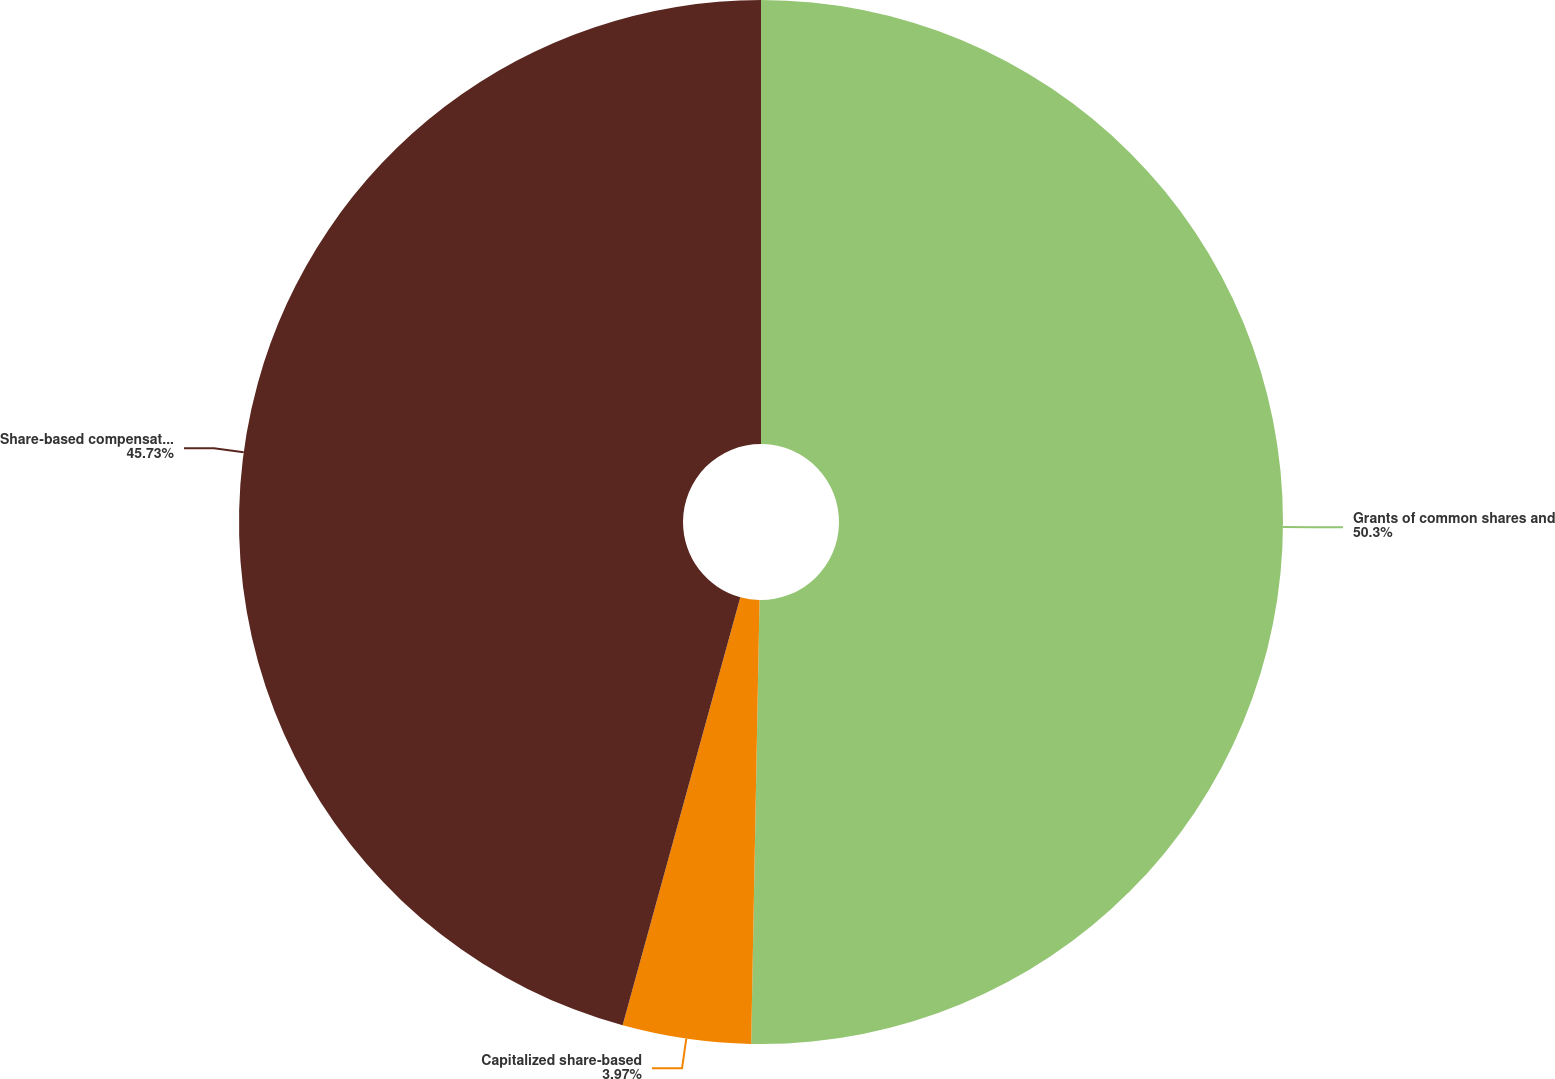Convert chart to OTSL. <chart><loc_0><loc_0><loc_500><loc_500><pie_chart><fcel>Grants of common shares and<fcel>Capitalized share-based<fcel>Share-based compensation<nl><fcel>50.3%<fcel>3.97%<fcel>45.73%<nl></chart> 